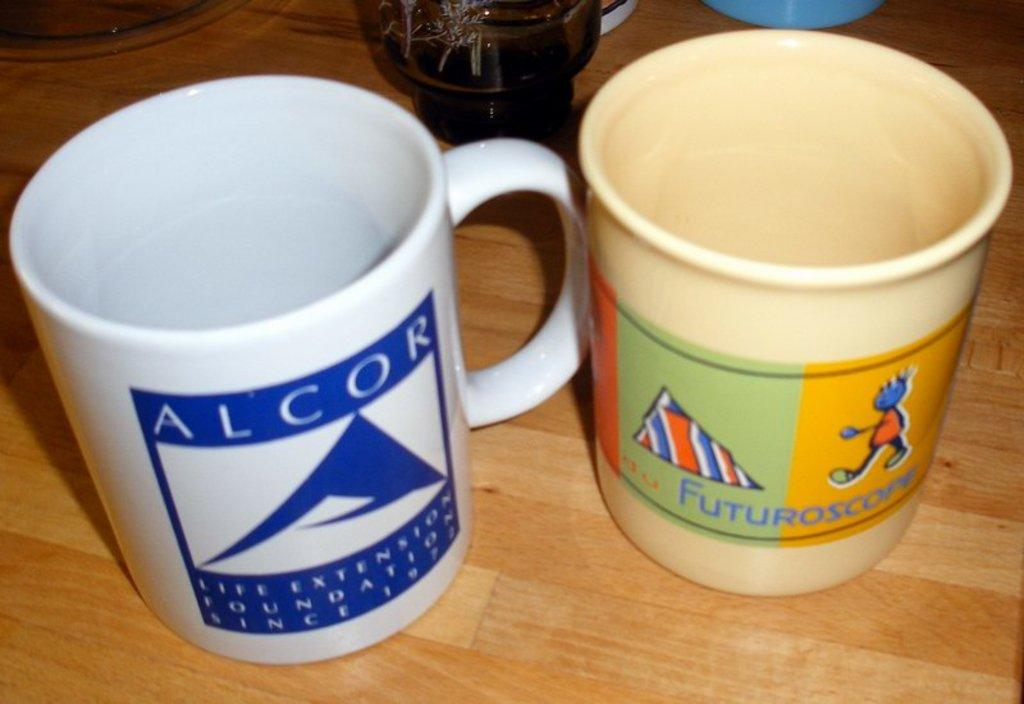What objects are present in the image? There are cups in the image. Where are the cups located? The cups are on a wooden table. What features can be seen on the cups? The cups have logos, text, and pictures. What type of cattle can be seen in the image? There are no cattle present in the image; it features cups on a wooden table. What request is being made in the image? There is no request being made in the image; it simply shows cups with logos, text, and pictures. 